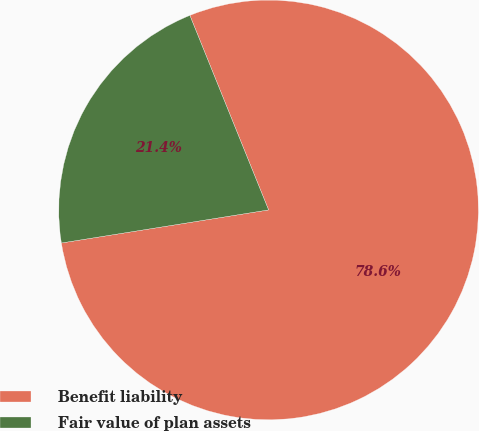Convert chart to OTSL. <chart><loc_0><loc_0><loc_500><loc_500><pie_chart><fcel>Benefit liability<fcel>Fair value of plan assets<nl><fcel>78.6%<fcel>21.4%<nl></chart> 